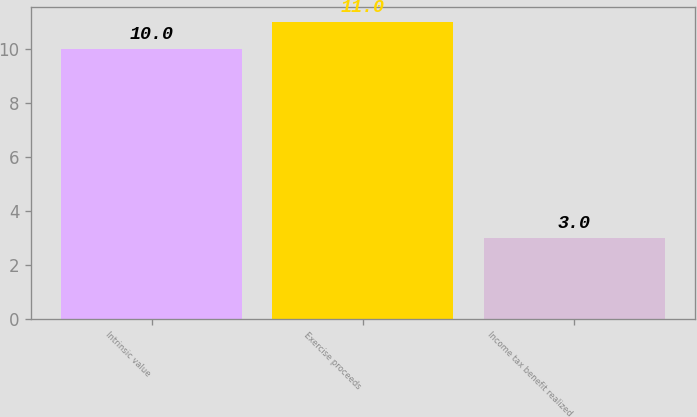Convert chart. <chart><loc_0><loc_0><loc_500><loc_500><bar_chart><fcel>Intrinsic value<fcel>Exercise proceeds<fcel>Income tax benefit realized<nl><fcel>10<fcel>11<fcel>3<nl></chart> 